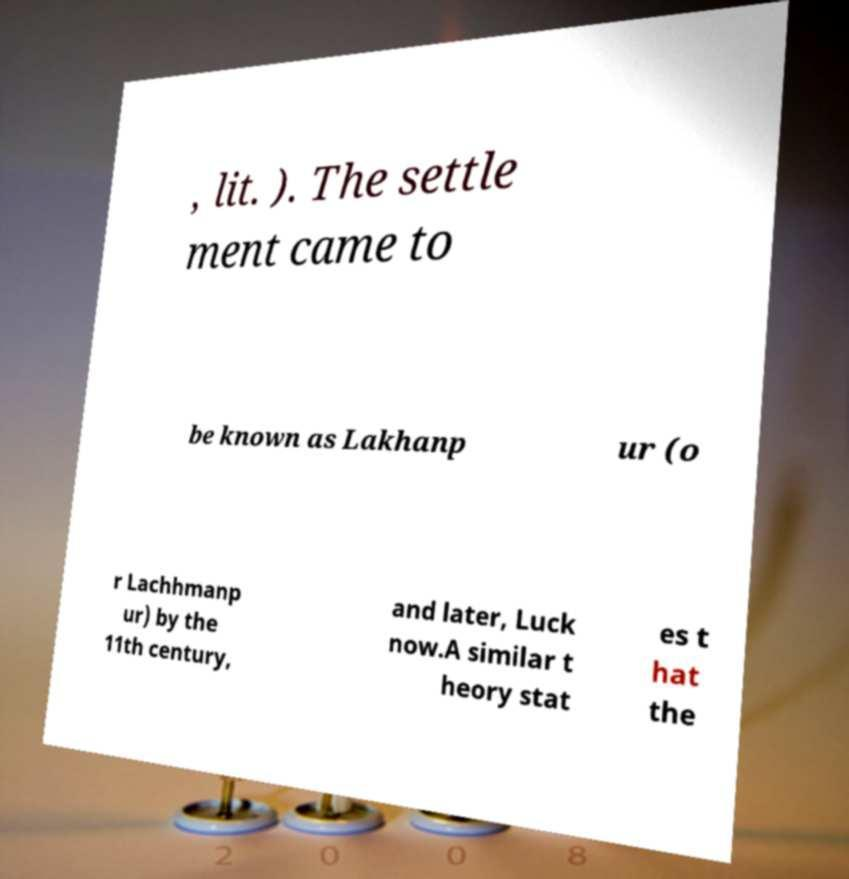Please read and relay the text visible in this image. What does it say? , lit. ). The settle ment came to be known as Lakhanp ur (o r Lachhmanp ur) by the 11th century, and later, Luck now.A similar t heory stat es t hat the 